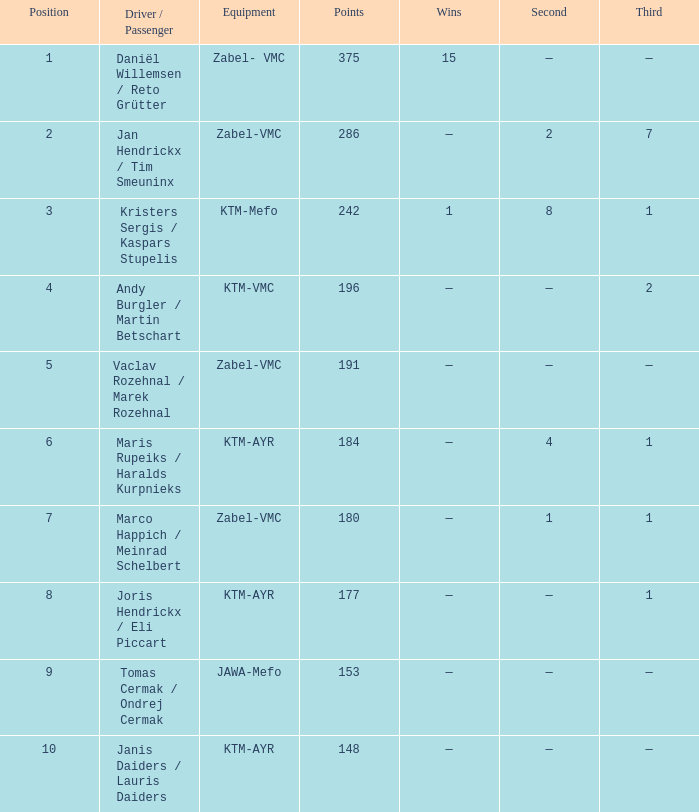Who was the driver/passengar when the position was smaller than 8, the third was 1, and there was 1 win? Kristers Sergis / Kaspars Stupelis. 